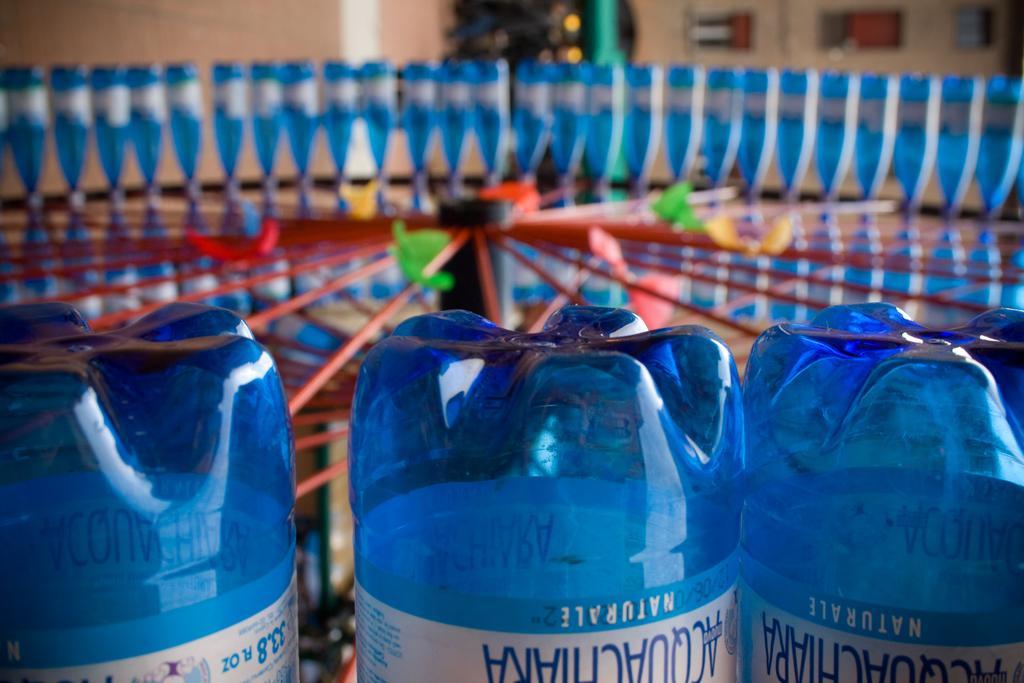Describe this image in one or two sentences. There are many bottles which are in blue color. 